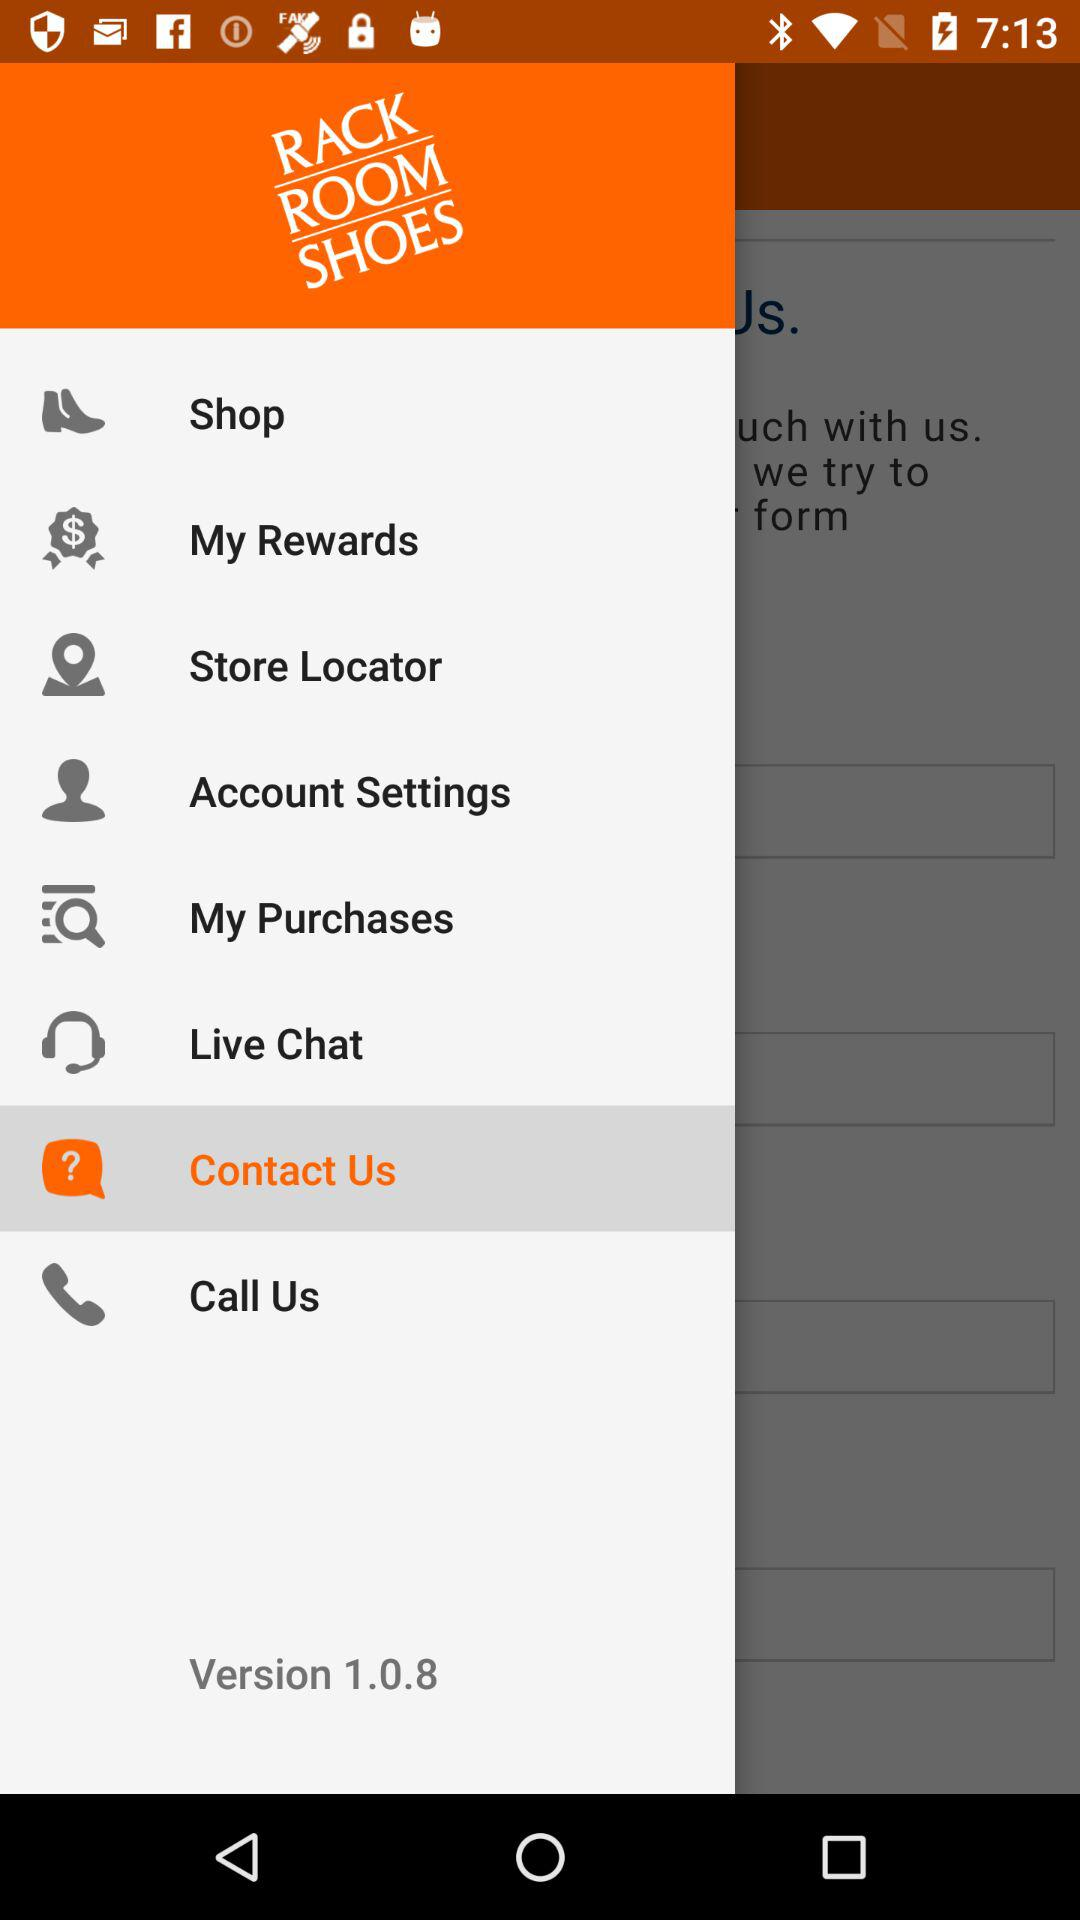How many items are in the footer?
Answer the question using a single word or phrase. 8 